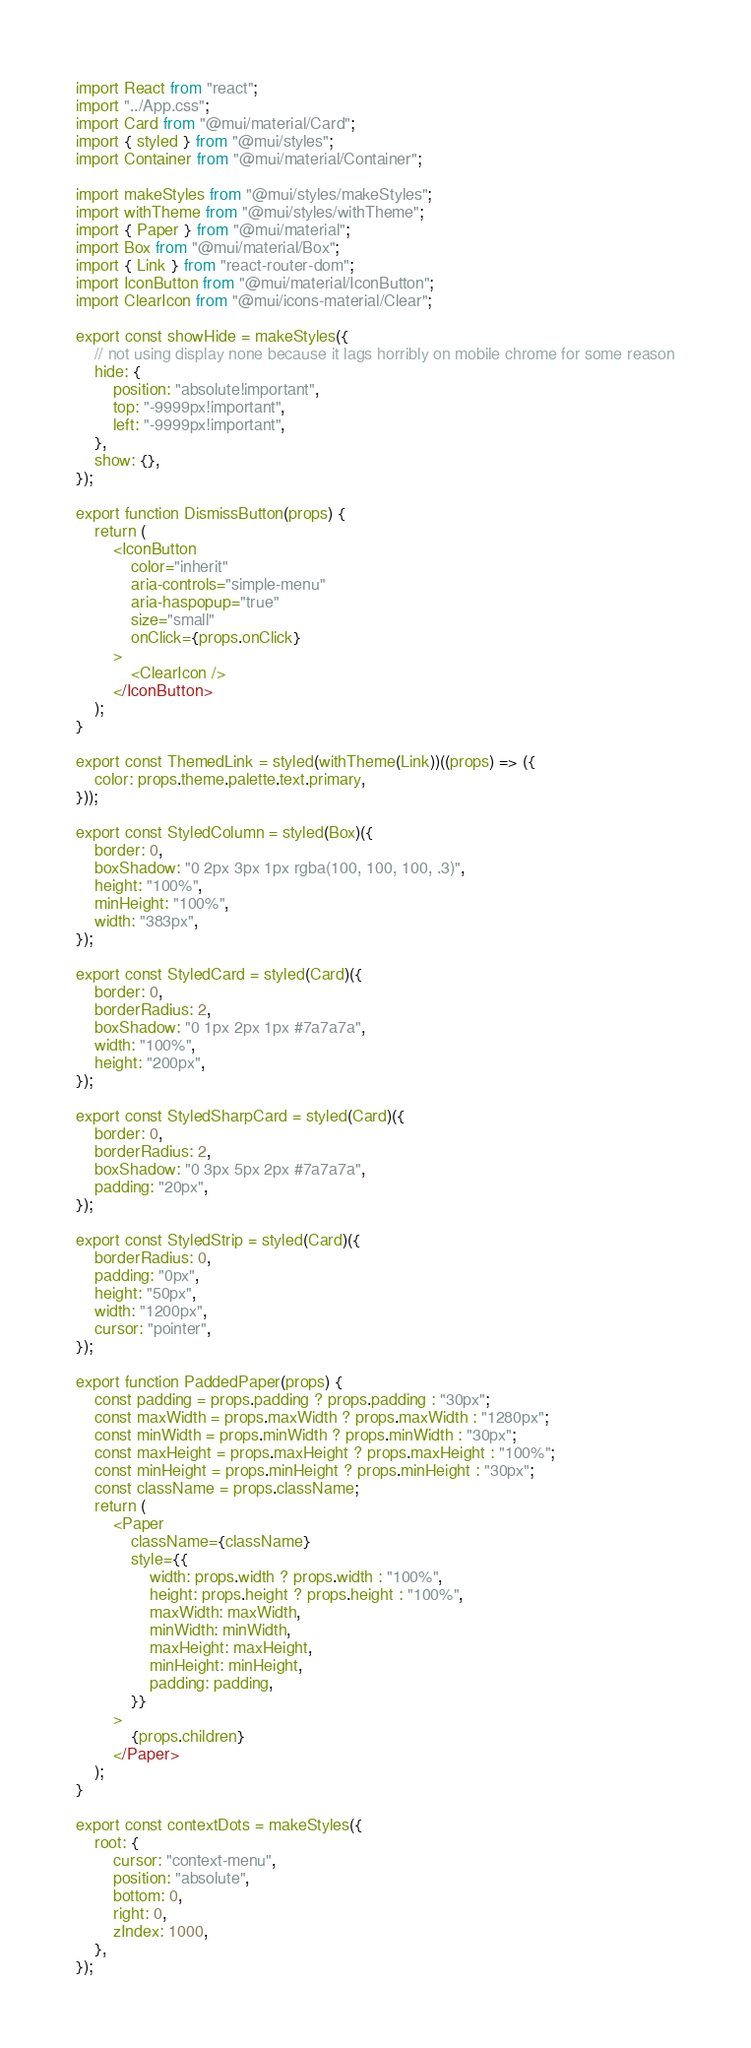Convert code to text. <code><loc_0><loc_0><loc_500><loc_500><_JavaScript_>import React from "react";
import "../App.css";
import Card from "@mui/material/Card";
import { styled } from "@mui/styles";
import Container from "@mui/material/Container";

import makeStyles from "@mui/styles/makeStyles";
import withTheme from "@mui/styles/withTheme";
import { Paper } from "@mui/material";
import Box from "@mui/material/Box";
import { Link } from "react-router-dom";
import IconButton from "@mui/material/IconButton";
import ClearIcon from "@mui/icons-material/Clear";

export const showHide = makeStyles({
    // not using display none because it lags horribly on mobile chrome for some reason
    hide: {
        position: "absolute!important",
        top: "-9999px!important",
        left: "-9999px!important",
    },
    show: {},
});

export function DismissButton(props) {
    return (
        <IconButton
            color="inherit"
            aria-controls="simple-menu"
            aria-haspopup="true"
            size="small"
            onClick={props.onClick}
        >
            <ClearIcon />
        </IconButton>
    );
}

export const ThemedLink = styled(withTheme(Link))((props) => ({
    color: props.theme.palette.text.primary,
}));

export const StyledColumn = styled(Box)({
    border: 0,
    boxShadow: "0 2px 3px 1px rgba(100, 100, 100, .3)",
    height: "100%",
    minHeight: "100%",
    width: "383px",
});

export const StyledCard = styled(Card)({
    border: 0,
    borderRadius: 2,
    boxShadow: "0 1px 2px 1px #7a7a7a",
    width: "100%",
    height: "200px",
});

export const StyledSharpCard = styled(Card)({
    border: 0,
    borderRadius: 2,
    boxShadow: "0 3px 5px 2px #7a7a7a",
    padding: "20px",
});

export const StyledStrip = styled(Card)({
    borderRadius: 0,
    padding: "0px",
    height: "50px",
    width: "1200px",
    cursor: "pointer",
});

export function PaddedPaper(props) {
    const padding = props.padding ? props.padding : "30px";
    const maxWidth = props.maxWidth ? props.maxWidth : "1280px";
    const minWidth = props.minWidth ? props.minWidth : "30px";
    const maxHeight = props.maxHeight ? props.maxHeight : "100%";
    const minHeight = props.minHeight ? props.minHeight : "30px";
    const className = props.className;
    return (
        <Paper
            className={className}
            style={{
                width: props.width ? props.width : "100%",
                height: props.height ? props.height : "100%",
                maxWidth: maxWidth,
                minWidth: minWidth,
                maxHeight: maxHeight,
                minHeight: minHeight,
                padding: padding,
            }}
        >
            {props.children}
        </Paper>
    );
}

export const contextDots = makeStyles({
    root: {
        cursor: "context-menu",
        position: "absolute",
        bottom: 0,
        right: 0,
        zIndex: 1000,
    },
});
</code> 